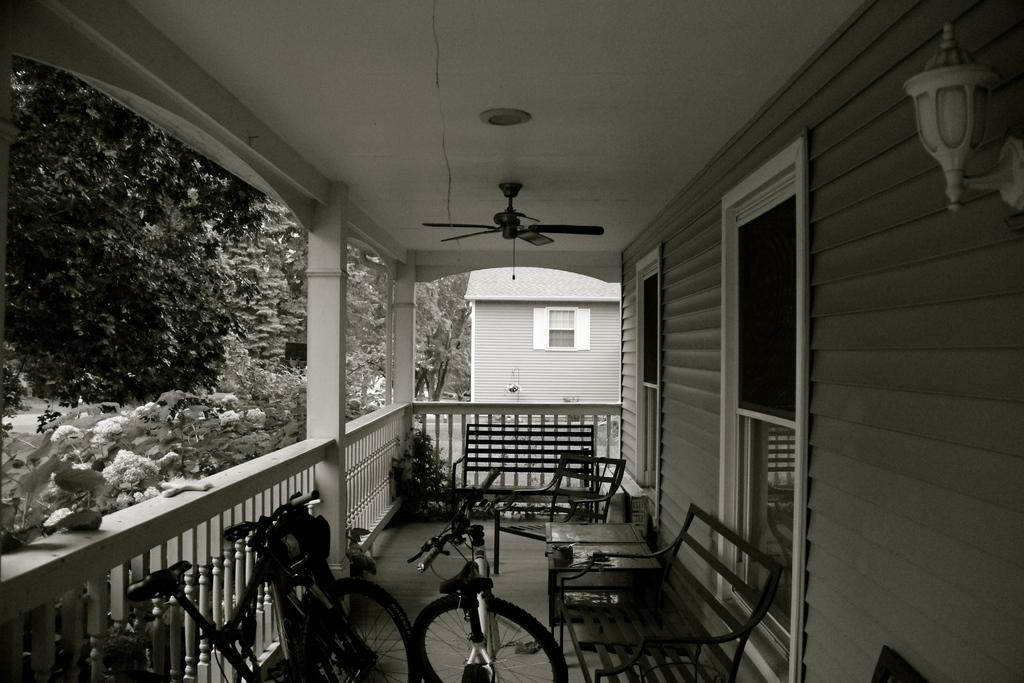What is the color scheme of the image? The image is black and white. What type of furniture can be seen in the image? There are chairs and a table in the image. What mode of transportation is present in the image? There are bicycles in the image. What type of vegetation is visible in the image? There are plants and trees in the image. What appliance can be seen in the image? There is a fan in the image. Where is the gun hidden in the image? There is no gun present in the image. What type of stick can be seen in the image? There is no stick present in the image. 